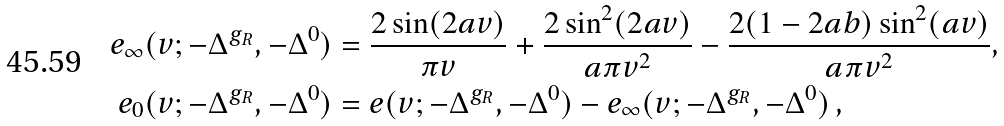<formula> <loc_0><loc_0><loc_500><loc_500>e _ { \infty } ( v ; - \Delta ^ { g _ { R } } , - \Delta ^ { 0 } ) & = \frac { 2 \sin ( 2 a v ) } { \pi v } + \frac { 2 \sin ^ { 2 } ( 2 a v ) } { a \pi v ^ { 2 } } - \frac { 2 ( 1 - 2 a b ) \sin ^ { 2 } ( a v ) } { a \pi v ^ { 2 } } , \\ e _ { 0 } ( v ; - \Delta ^ { g _ { R } } , - \Delta ^ { 0 } ) & = e ( v ; - \Delta ^ { g _ { R } } , - \Delta ^ { 0 } ) - e _ { \infty } ( v ; - \Delta ^ { g _ { R } } , - \Delta ^ { 0 } ) \, ,</formula> 